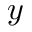Convert formula to latex. <formula><loc_0><loc_0><loc_500><loc_500>y</formula> 